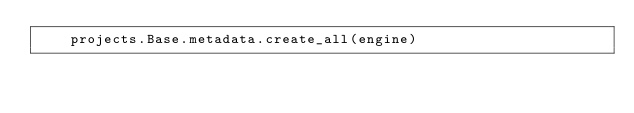Convert code to text. <code><loc_0><loc_0><loc_500><loc_500><_Python_>    projects.Base.metadata.create_all(engine)

</code> 